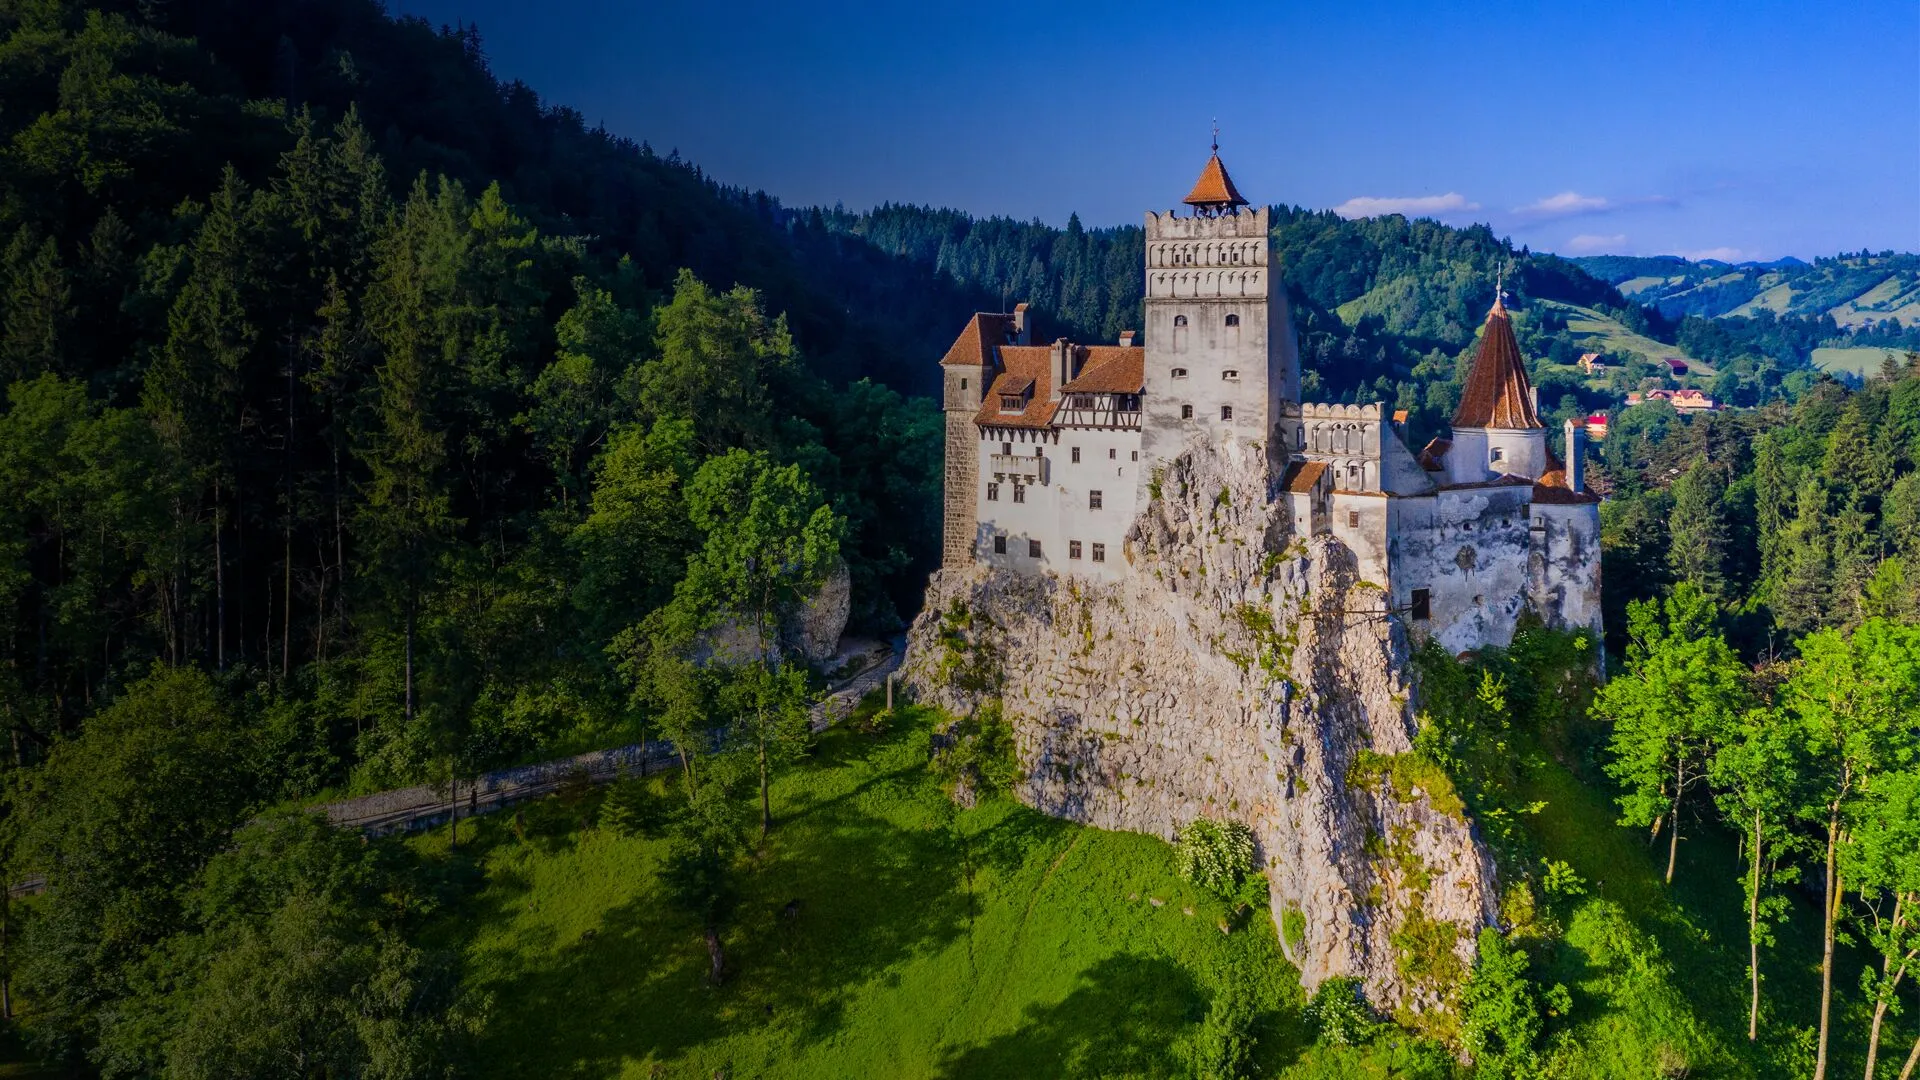What modern events or activities could this castle host? Bran Castle, with its rich history and breathtaking architecture, could serve as an iconic venue for various modern events. Imagine it hosting elegant weddings, where couples exchange vows in the picturesque courtyard or the grand hall. Film festivals could feature historical and horror genres, leveraging the castle's storied past and its association with Dracula. Cultural events celebrating Romanian history and folklore would find a fitting backdrop within the castle walls. It could also serve as a unique venue for corporate retreats, offering team-building activities and immersive experiences in a historic setting. Concerts and theatrical performances would be particularly enchanting, with the castle's architecture providing natural acoustics and a dramatic ambiance. The castle could also participate in historical reenactments, allowing visitors to immerse themselves in the medieval period through interactive exhibits and costumed guides. 